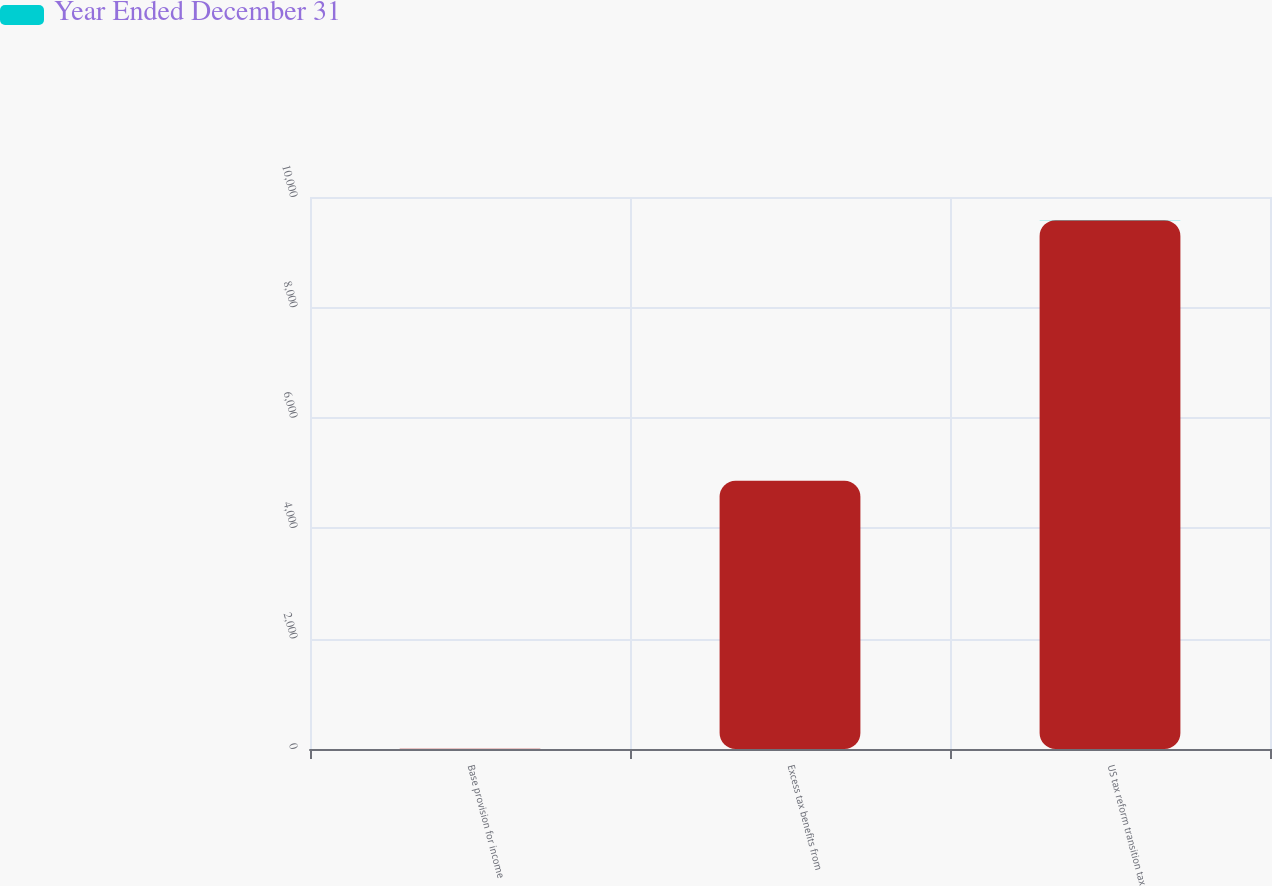Convert chart to OTSL. <chart><loc_0><loc_0><loc_500><loc_500><stacked_bar_chart><ecel><fcel>Base provision for income<fcel>Excess tax benefits from<fcel>US tax reform transition tax<nl><fcel>nan<fcel>4<fcel>4859<fcel>9581<nl><fcel>Year Ended December 31<fcel>1<fcel>2<fcel>4<nl></chart> 